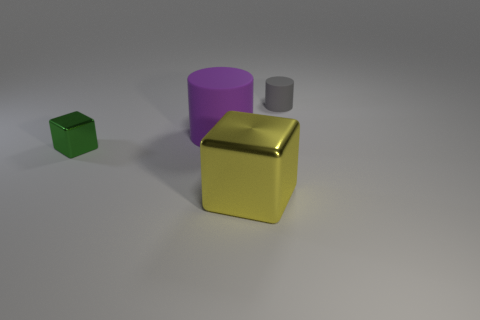Do the big object left of the large yellow metal cube and the gray cylinder have the same material?
Ensure brevity in your answer.  Yes. Is there anything else that has the same material as the tiny block?
Keep it short and to the point. Yes. What number of large purple matte cylinders are on the right side of the large thing that is behind the cube on the right side of the tiny green block?
Provide a short and direct response. 0. The purple rubber thing is what size?
Provide a succinct answer. Large. Is the large metallic cube the same color as the small rubber object?
Provide a short and direct response. No. What size is the matte cylinder left of the tiny gray matte object?
Offer a terse response. Large. Is the color of the cylinder that is to the right of the yellow shiny cube the same as the big thing in front of the big purple cylinder?
Provide a succinct answer. No. What number of other things are the same shape as the purple matte object?
Ensure brevity in your answer.  1. Are there an equal number of yellow metal cubes that are on the right side of the large metal block and small metal objects that are behind the purple cylinder?
Your answer should be very brief. Yes. Is the material of the tiny thing that is to the right of the tiny green metallic thing the same as the cylinder that is in front of the small gray matte object?
Make the answer very short. Yes. 